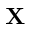Convert formula to latex. <formula><loc_0><loc_0><loc_500><loc_500>X</formula> 